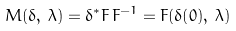<formula> <loc_0><loc_0><loc_500><loc_500>M ( \delta , \, \lambda ) = \delta ^ { * } F \, F ^ { - 1 } = F ( \delta ( 0 ) , \, \lambda )</formula> 